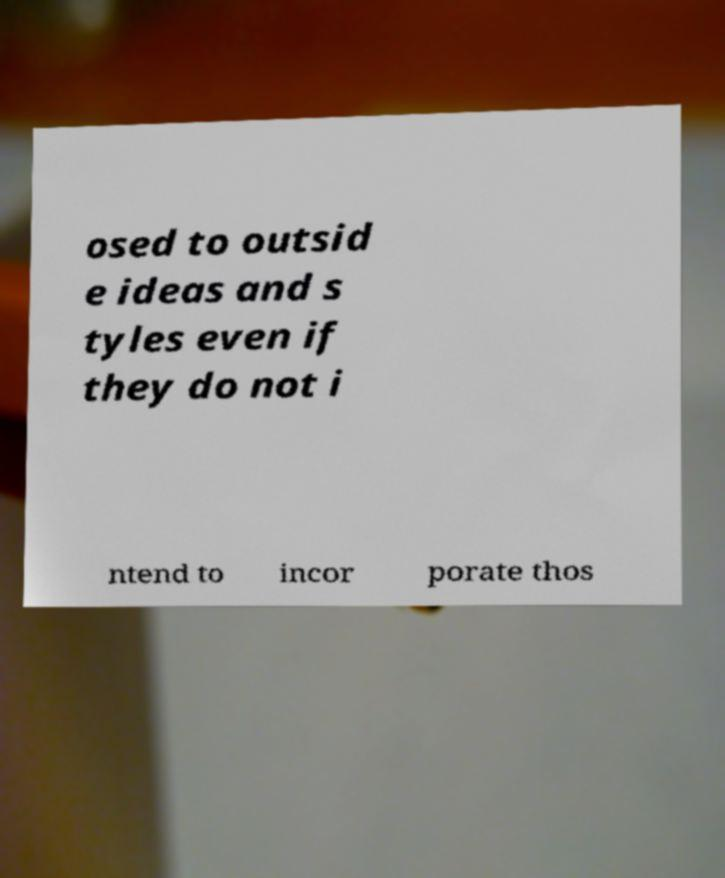Could you extract and type out the text from this image? osed to outsid e ideas and s tyles even if they do not i ntend to incor porate thos 